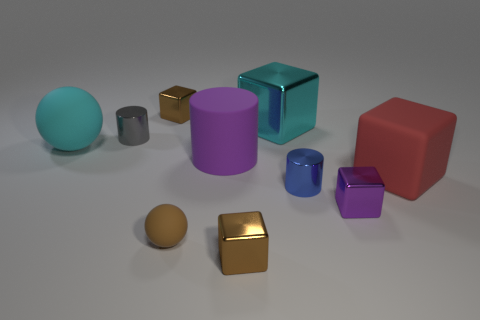Subtract all tiny shiny cylinders. How many cylinders are left? 1 Subtract all cylinders. How many objects are left? 7 Subtract all red blocks. How many blocks are left? 4 Subtract 2 balls. How many balls are left? 0 Subtract all red blocks. Subtract all brown balls. How many blocks are left? 4 Subtract all gray cylinders. How many brown spheres are left? 1 Subtract all small brown metallic cubes. Subtract all small metal cylinders. How many objects are left? 6 Add 7 red rubber blocks. How many red rubber blocks are left? 8 Add 8 big metallic things. How many big metallic things exist? 9 Subtract 0 cyan cylinders. How many objects are left? 10 